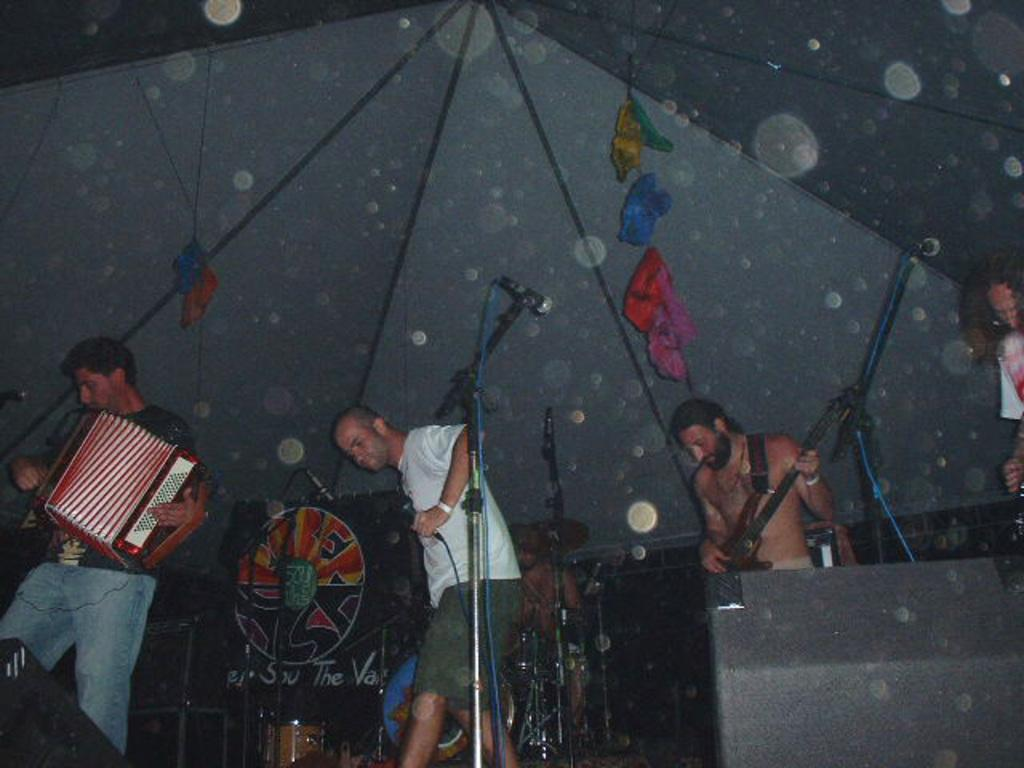What are the people in the middle of the image doing? The people are standing in the middle of the image and holding musical instruments. What else are the people holding in the image? The people are also holding microphones. Can you describe the structure at the top of the image? There is a tent at the top of the image. How many spies are present in the image? There is no indication of spies in the image; it features people holding musical instruments and microphones. What type of power source is used to operate the instruments in the image? The image does not provide information about the power source for the instruments. 